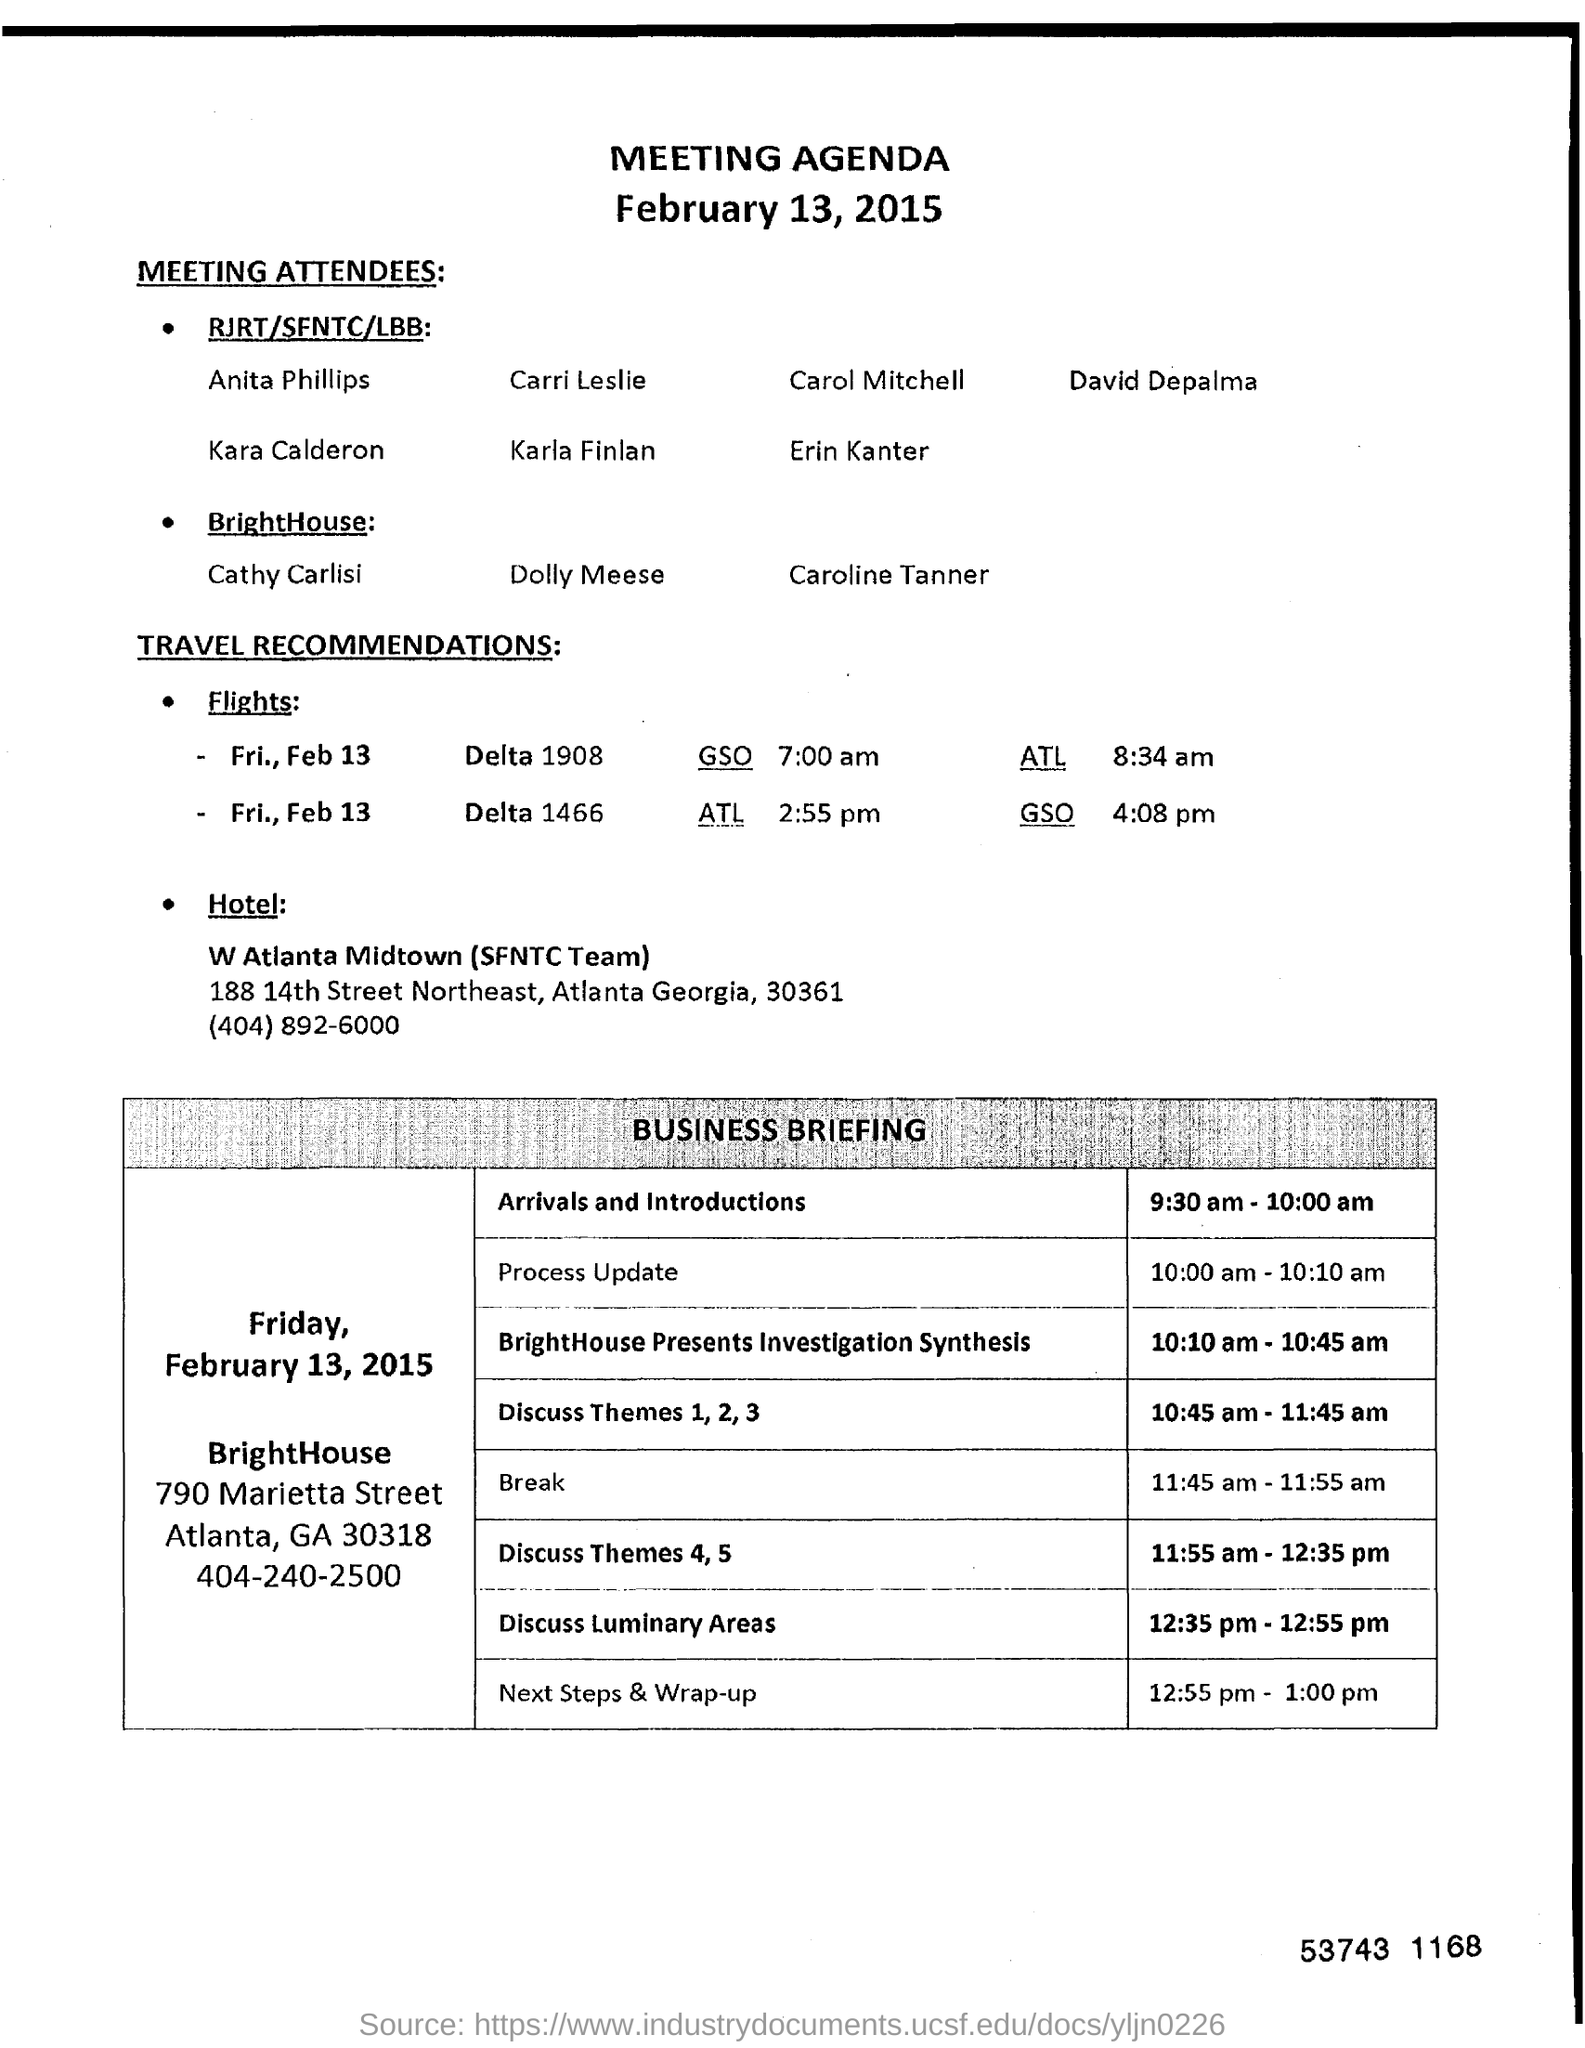Specify some key components in this picture. The meeting will take place on February 13, 2015. The process update is scheduled for 10:00 am to 10:10 am. 